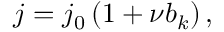<formula> <loc_0><loc_0><loc_500><loc_500>j = j _ { 0 } \left ( 1 + \nu b _ { k } \right ) ,</formula> 